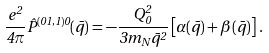Convert formula to latex. <formula><loc_0><loc_0><loc_500><loc_500>\frac { e ^ { 2 } } { 4 \pi } \hat { P } ^ { ( 0 1 , 1 ) 0 } ( \bar { q } ) = - \frac { Q _ { 0 } ^ { 2 } } { 3 m _ { N } \bar { q } ^ { 2 } } \left [ \alpha ( \bar { q } ) + \beta ( \bar { q } ) \right ] \, .</formula> 